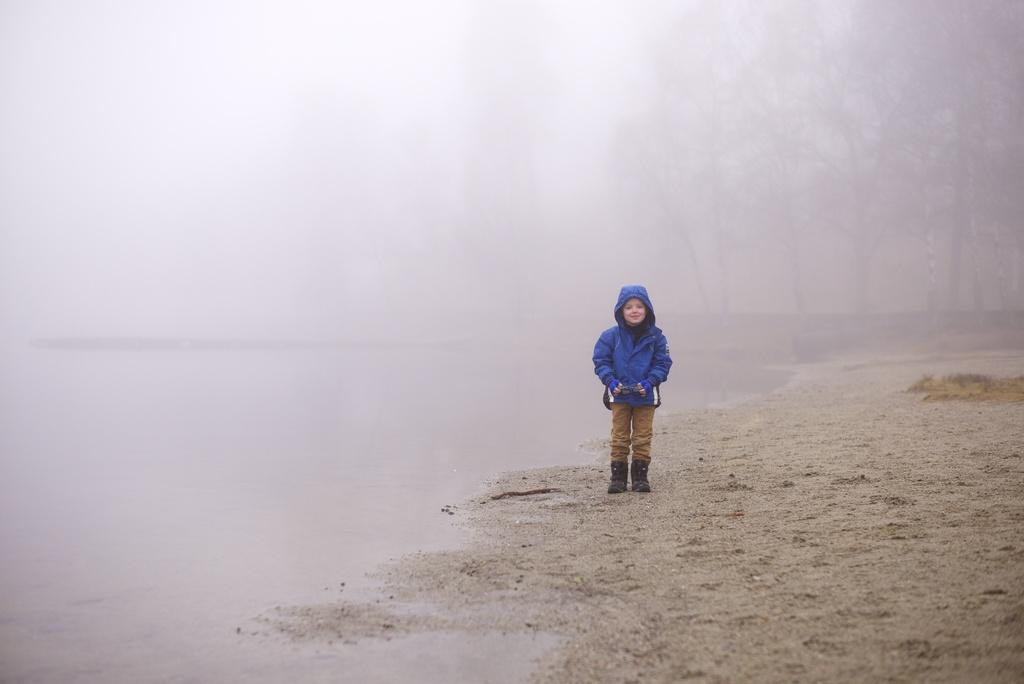What is the main subject of the image? The main subject of the image is a kid. Where is the kid located in the image? The kid is standing on a seashore. What can be seen in the background of the image? There are trees and fog in the background of the image. What type of acoustics can be heard in the image? There is no information about sounds or acoustics in the image, so it cannot be determined from the image. 